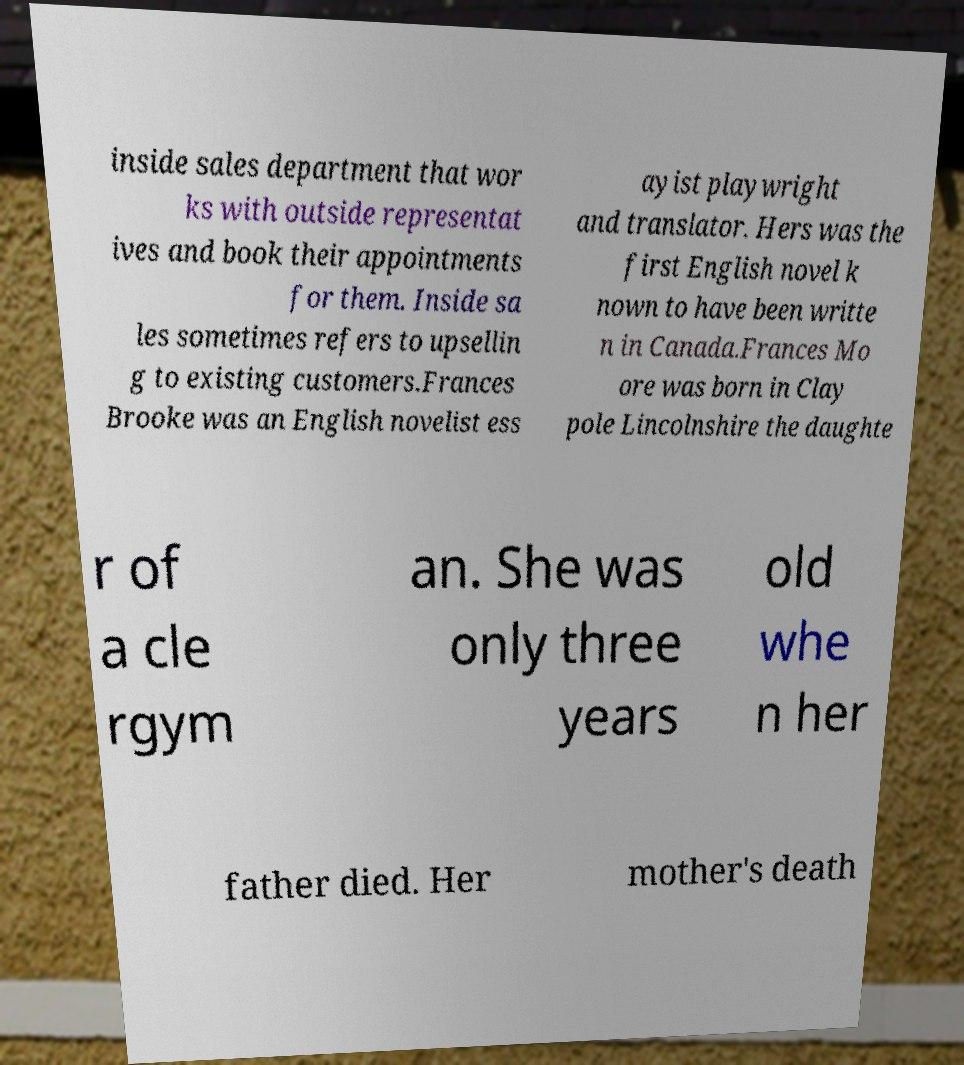Can you accurately transcribe the text from the provided image for me? inside sales department that wor ks with outside representat ives and book their appointments for them. Inside sa les sometimes refers to upsellin g to existing customers.Frances Brooke was an English novelist ess ayist playwright and translator. Hers was the first English novel k nown to have been writte n in Canada.Frances Mo ore was born in Clay pole Lincolnshire the daughte r of a cle rgym an. She was only three years old whe n her father died. Her mother's death 